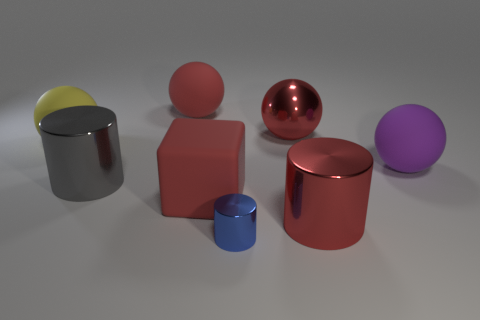What is the material of the large sphere that is in front of the yellow object?
Keep it short and to the point. Rubber. What number of other objects are there of the same shape as the small object?
Your answer should be very brief. 2. Is the yellow thing the same shape as the large purple thing?
Ensure brevity in your answer.  Yes. There is a yellow ball; are there any large red shiny things on the left side of it?
Provide a succinct answer. No. What number of things are either small blue cylinders or large cyan things?
Provide a succinct answer. 1. What number of other objects are the same size as the red matte cube?
Provide a succinct answer. 6. What number of large balls are both right of the gray cylinder and to the left of the large purple object?
Offer a very short reply. 2. There is a purple rubber thing on the right side of the big red cube; is its size the same as the sphere left of the gray metallic cylinder?
Keep it short and to the point. Yes. There is a matte block in front of the purple ball; what size is it?
Your response must be concise. Large. How many objects are either metal cylinders behind the tiny shiny cylinder or big rubber balls that are left of the red rubber cube?
Provide a succinct answer. 4. 